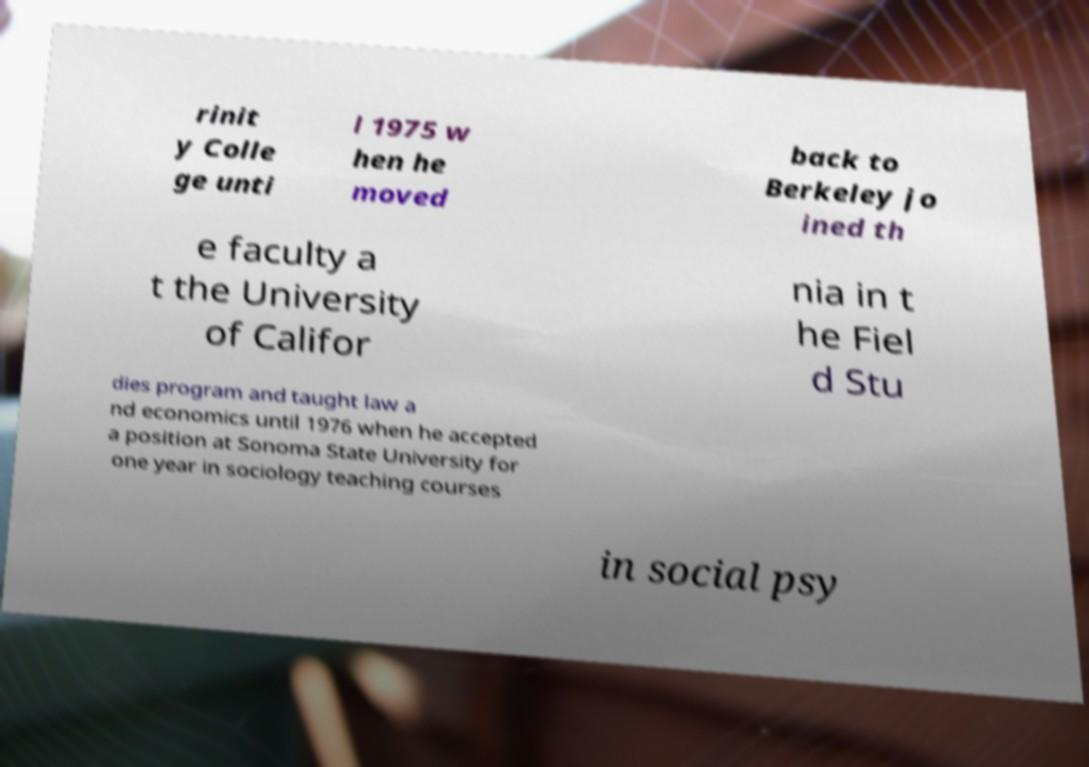What messages or text are displayed in this image? I need them in a readable, typed format. rinit y Colle ge unti l 1975 w hen he moved back to Berkeley jo ined th e faculty a t the University of Califor nia in t he Fiel d Stu dies program and taught law a nd economics until 1976 when he accepted a position at Sonoma State University for one year in sociology teaching courses in social psy 